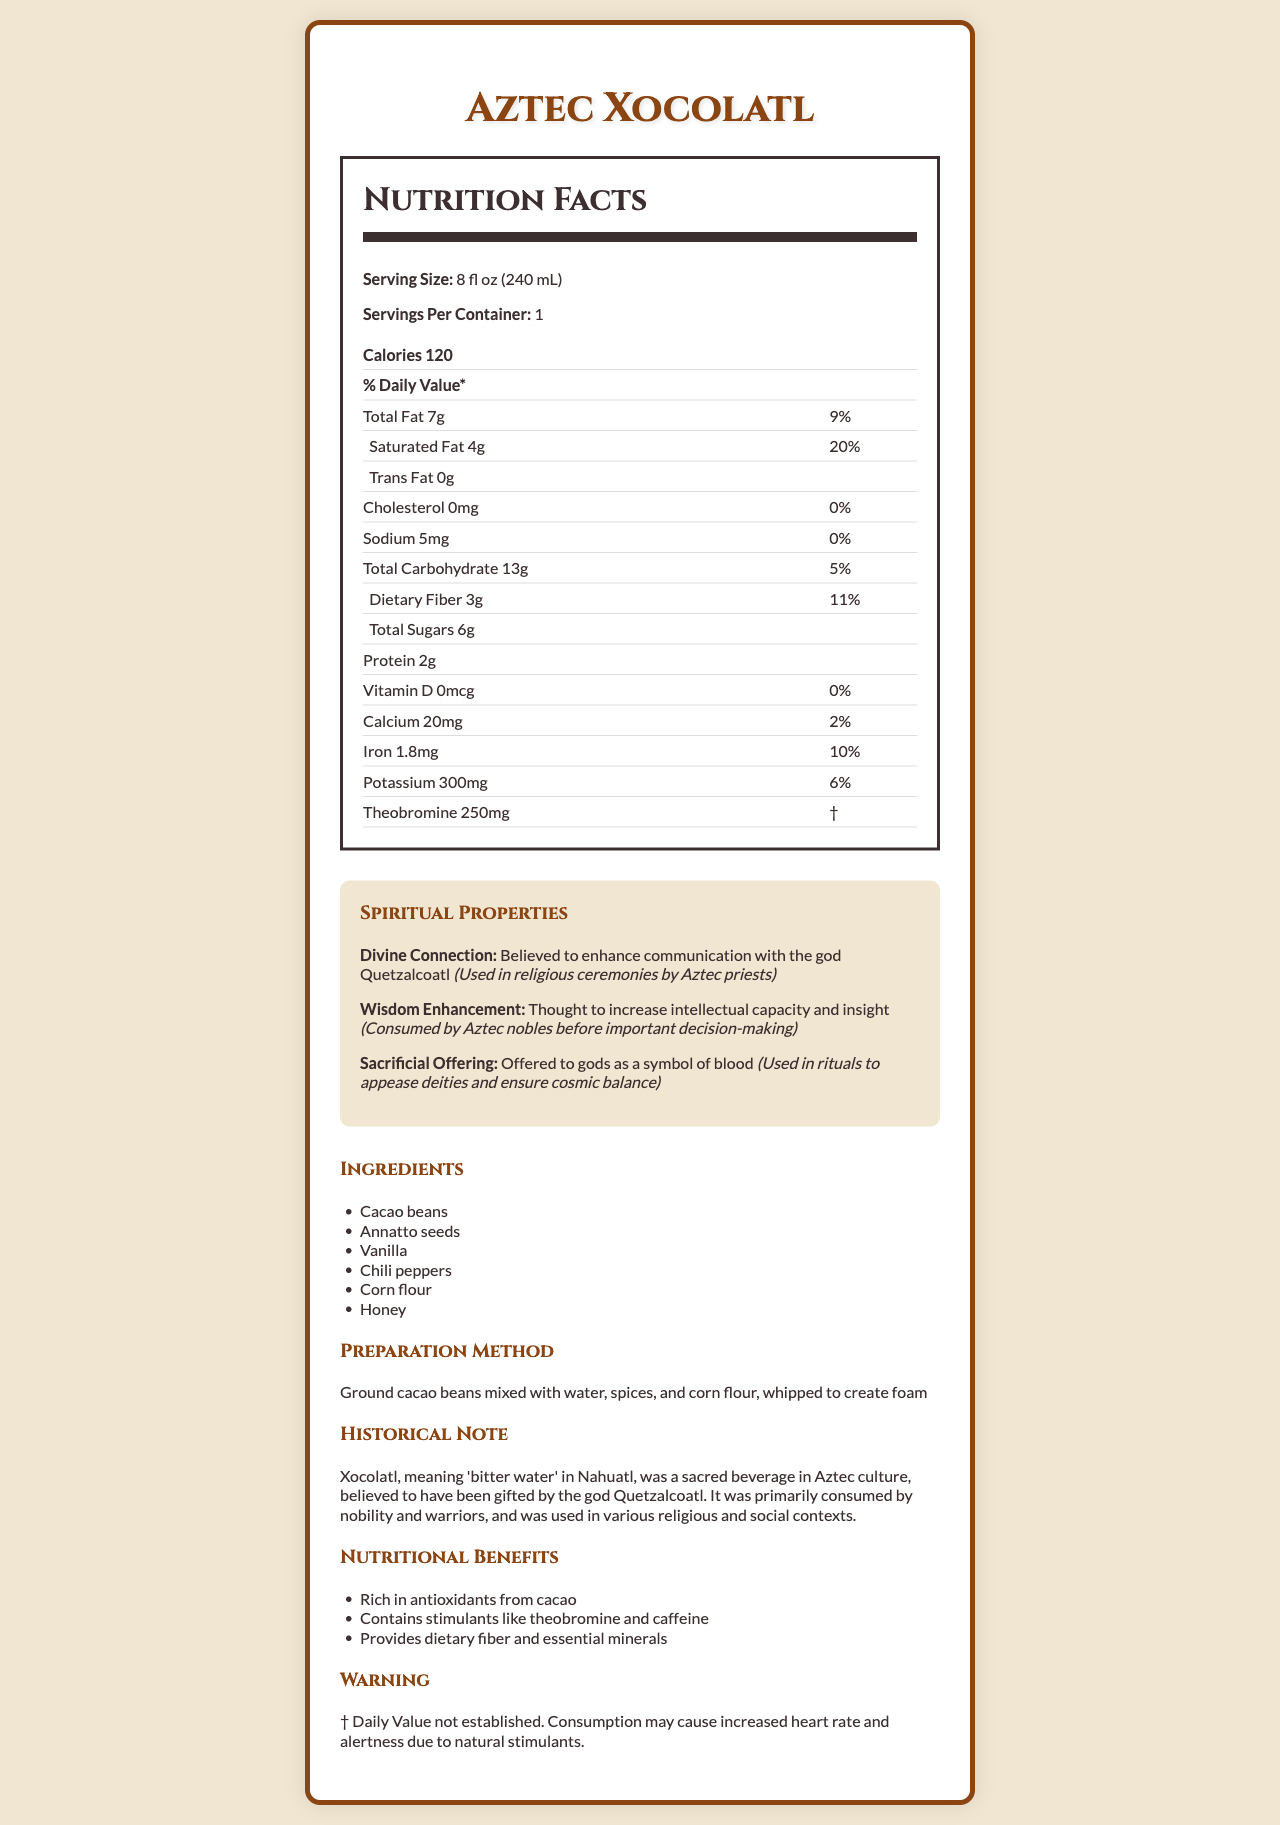what is the serving size for Aztec Xocolatl? The serving size is explicitly listed as 8 fl oz (240 mL) on the nutrition facts label.
Answer: 8 fl oz (240 mL) how many calories are in one serving? The document states that there are 120 calories per serving.
Answer: 120 what is the sodium content in Aztec Xocolatl? The sodium content is directly listed as 5mg on the nutrition facts label.
Answer: 5mg how much protein does Aztec Xocolatl contain per serving? The amount of protein is listed as 2g per serving on the nutrition facts label.
Answer: 2g what is the historical significance of xocolatl according to the document? The historical note section provides a detailed explanation of the significance of xocolatl in Aztec culture.
Answer: Xocolatl was a sacred beverage in Aztec culture, believed to have been gifted by the god Quetzalcoatl. It was primarily consumed by nobility and warriors, and was used in various religious and social contexts. which of the following ingredients is NOT in Aztec Xocolatl? A. Annatto seeds B. Vanilla C. Sugar D. Chili peppers The ingredients listed are Cacao beans, Annatto seeds, Vanilla, Chili peppers, Corn flour, and Honey; Sugar is not mentioned.
Answer: C what percentage of the daily value for saturated fat does one serving of Aztec Xocolatl contain? A. 9% B. 20% C. 5% D. 11% The daily value percentage for saturated fat is listed as 20%.
Answer: B does Aztec Xocolatl contain any trans fat? The document specifically lists 0g of trans fat, indicating it contains none.
Answer: No can Aztec Xocolatl be considered a high-source of dietary fiber? The document shows that Aztec Xocolatl provides 11% of the daily value for dietary fiber, which can be considered significant.
Answer: Yes what are the spiritual properties of Aztec Xocolatl mentioned in the document? The spiritual properties of Aztec Xocolatl mentioned are Divine Connection, Wisdom Enhancement, and Sacrificial Offering, with detailed descriptions and historical significance for each.
Answer: Divine Connection, Wisdom Enhancement, Sacrificial Offering what essential mineral in Aztec Xocolatl helps to improve iron intake? Iron is listed with an amount of 1.8mg and 10% of the daily value, indicating its role in improving iron intake.
Answer: Iron what is the primary historical note provided about xocolatl? The historical note provides detailed information about its sacred status and use in Aztec culture.
Answer: Xocolatl, meaning 'bitter water' in Nahuatl, was a sacred beverage in Aztec culture, believed to have been gifted by the god Quetzalcoatl. It was primarily consumed by nobility and warriors, and was used in various religious and social contexts. how many servings per container are there in Aztec Xocolatl? The nutrition facts label states that there is 1 serving per container.
Answer: 1 describe the main idea of the document The document thoroughly covers all aspects of Aztec Xocolatl, emphasizing its historical and spiritual significance along with its nutritional composition.
Answer: The document provides a detailed description of Aztec Xocolatl, including its nutritional facts, ingredients, preparation method, spiritual properties, historical significance, and nutritional benefits. It highlights the beverage's cultural importance in Aztec society and its use in various religious and social contexts. what is Aztec Xocolatl believed to enhance according to the spiritual properties section? The document mentions that Aztec Xocolatl is believed to enhance communication with the god Quetzalcoatl and increase intellectual capacity.
Answer: Communication with the god Quetzalcoatl and intellectual capacity what is the warning given about consuming Aztec Xocolatl? The warning section in the document mentions the effect of natural stimulants like theobromine and caffeine on heart rate and alertness.
Answer: Consumption may cause increased heart rate and alertness due to natural stimulants. how much calcium does Aztec Xocolatl provide? The nutrition facts label lists the calcium content as 20mg per serving.
Answer: 20mg does the document state when Aztec Xocolatl was first created? The document does not provide specific details about the exact time when Aztec Xocolatl was first created.
Answer: Not enough information what is the preparation method of Aztec Xocolatl? The preparation method section describes how the beverage is made by mixing ground cacao beans with water, spices, and corn flour, and then whipping it to create foam.
Answer: Ground cacao beans mixed with water, spices, and corn flour, whipped to create foam 